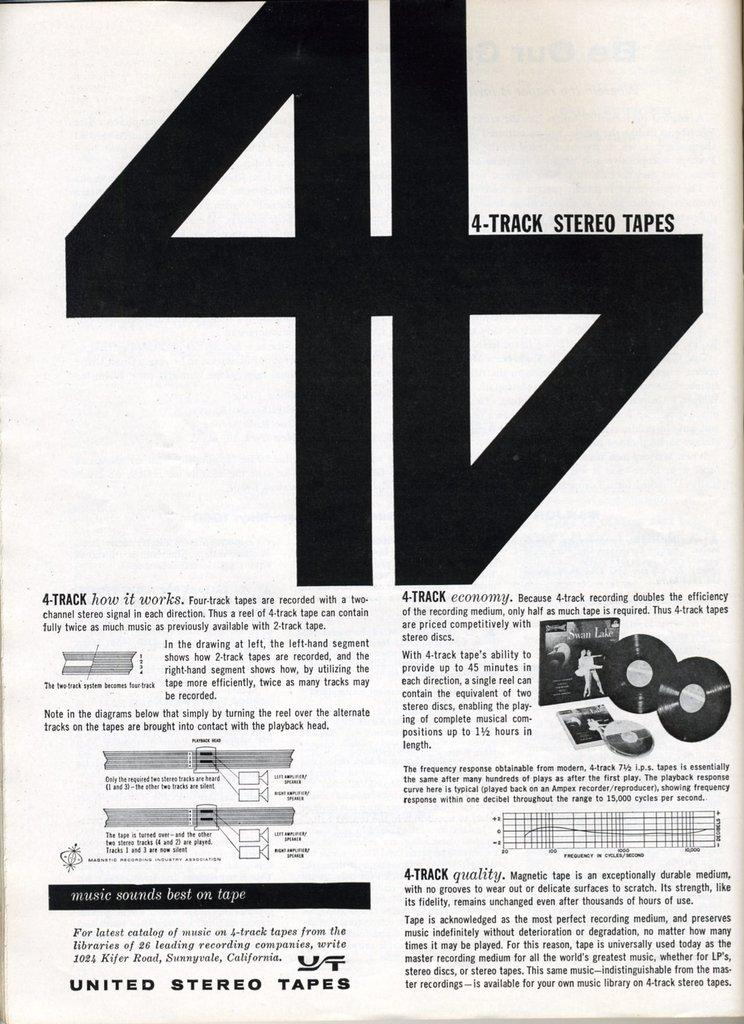<image>
Render a clear and concise summary of the photo. Page that says United Stereo Tapes on the bottom. 